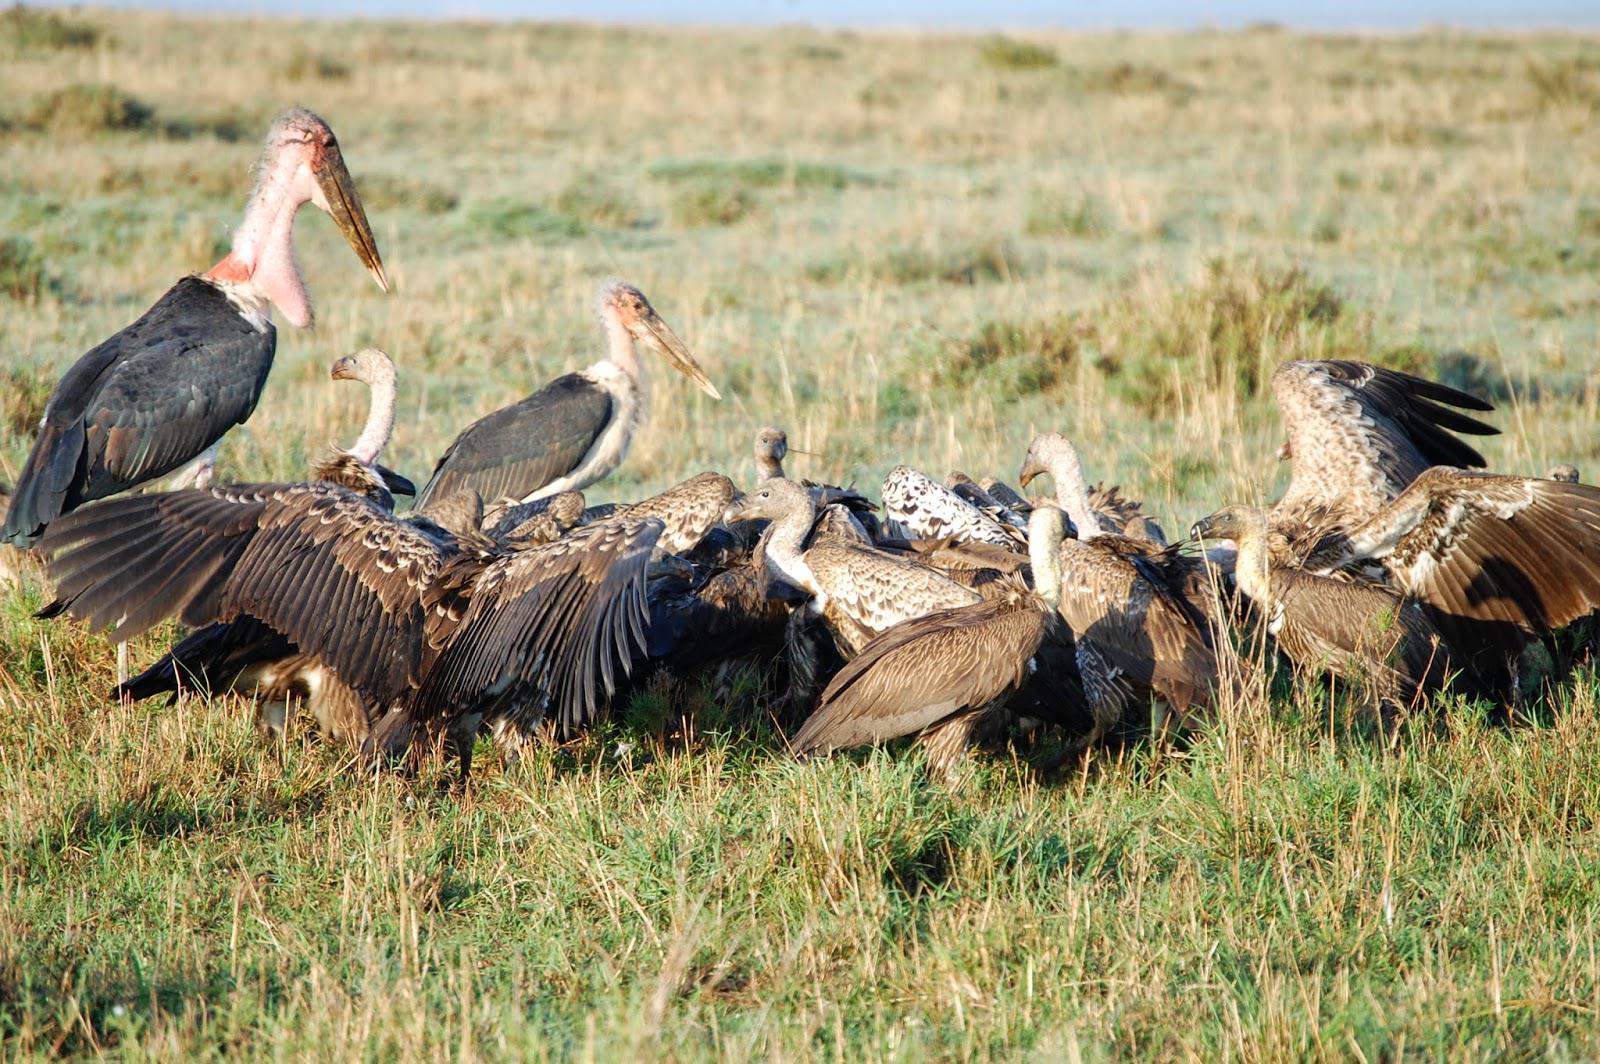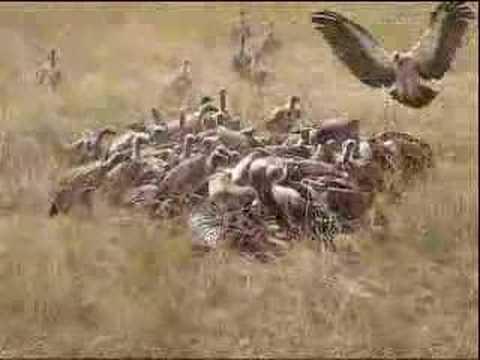The first image is the image on the left, the second image is the image on the right. Given the left and right images, does the statement "All vultures in one image are off the ground." hold true? Answer yes or no. No. The first image is the image on the left, the second image is the image on the right. Evaluate the accuracy of this statement regarding the images: "In 1 of the images, at least 1 bird is flying.". Is it true? Answer yes or no. Yes. 